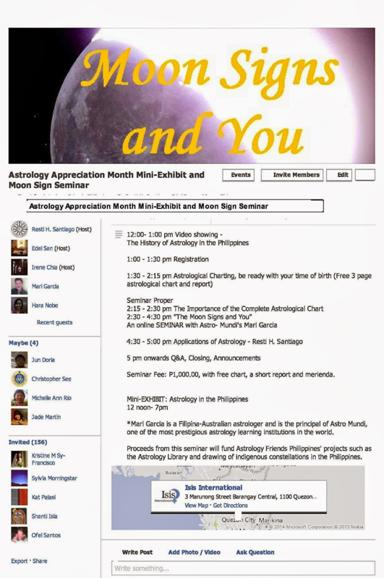Can you tell more about the video presentation on "The History of Astrology in the Philippines" mentioned in the schedule? The video presentation titled "The History of Astrology in the Philippines" is an introductory segment scheduled from 12:00 to 1:00 pm, designed to provide attendees with a foundational understanding of how astrology has been interpreted and used in the Philippines over the years. This historical perspective sets the stage for deeper dives into astrological concepts throughout the seminar. 